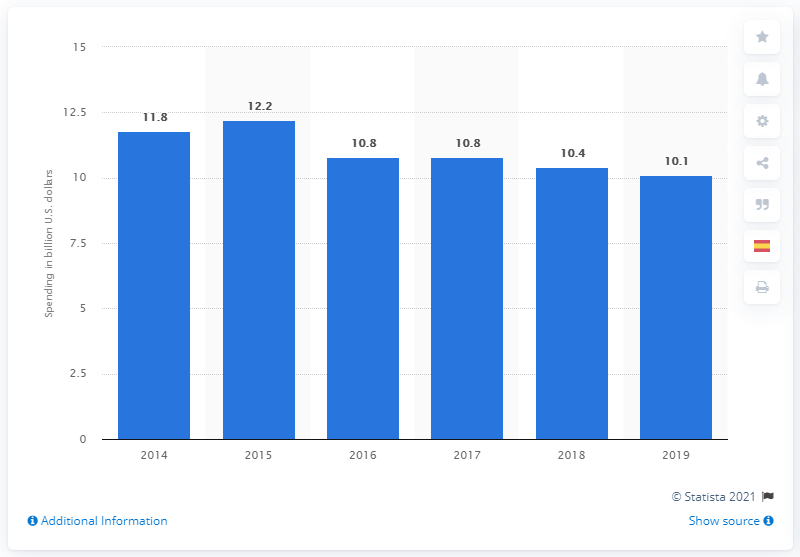Draw attention to some important aspects in this diagram. In 2019, the spending on chemical R&D in the United States totaled 10.1 billion USD. 